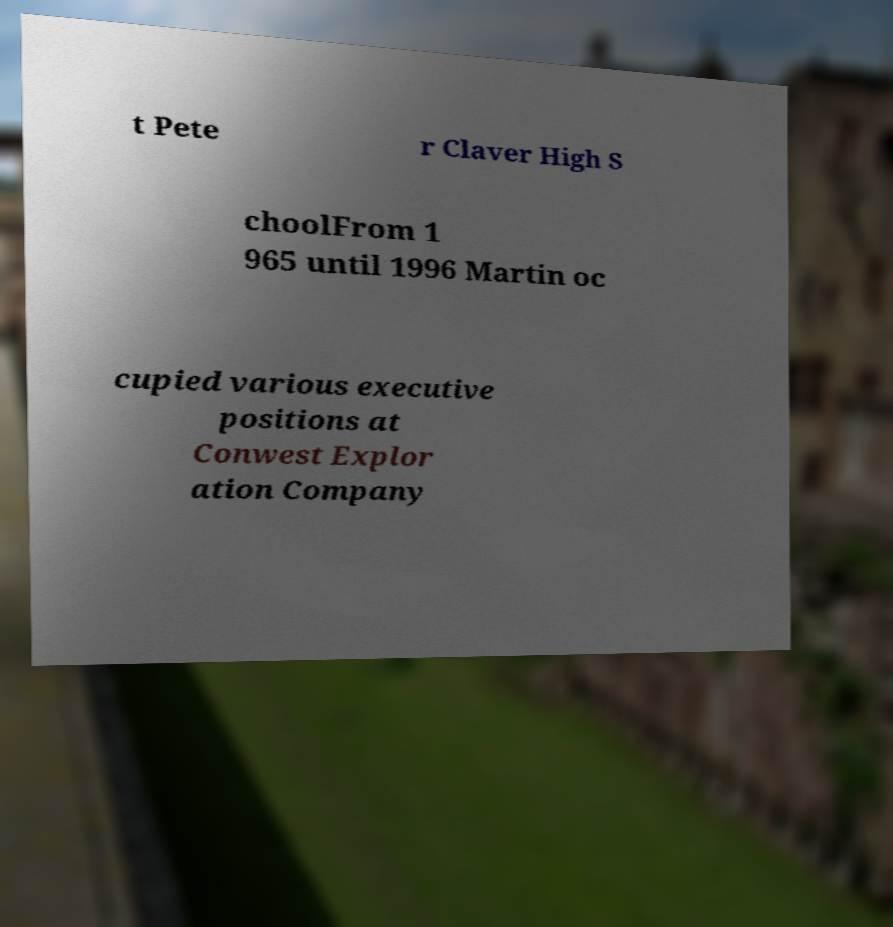Please identify and transcribe the text found in this image. t Pete r Claver High S choolFrom 1 965 until 1996 Martin oc cupied various executive positions at Conwest Explor ation Company 